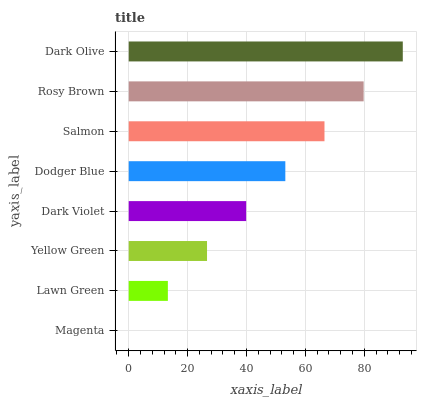Is Magenta the minimum?
Answer yes or no. Yes. Is Dark Olive the maximum?
Answer yes or no. Yes. Is Lawn Green the minimum?
Answer yes or no. No. Is Lawn Green the maximum?
Answer yes or no. No. Is Lawn Green greater than Magenta?
Answer yes or no. Yes. Is Magenta less than Lawn Green?
Answer yes or no. Yes. Is Magenta greater than Lawn Green?
Answer yes or no. No. Is Lawn Green less than Magenta?
Answer yes or no. No. Is Dodger Blue the high median?
Answer yes or no. Yes. Is Dark Violet the low median?
Answer yes or no. Yes. Is Lawn Green the high median?
Answer yes or no. No. Is Dodger Blue the low median?
Answer yes or no. No. 